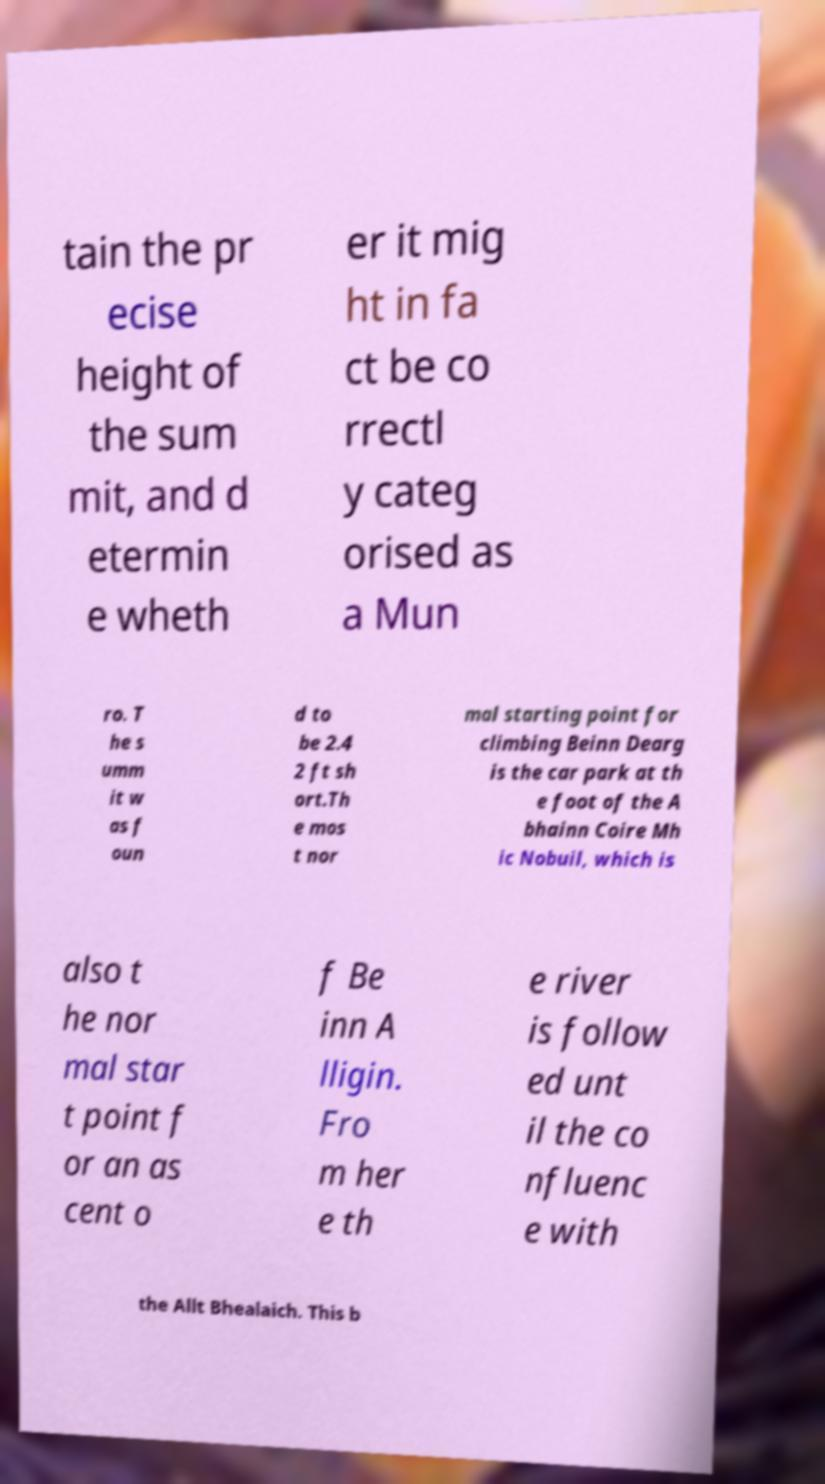Can you read and provide the text displayed in the image?This photo seems to have some interesting text. Can you extract and type it out for me? tain the pr ecise height of the sum mit, and d etermin e wheth er it mig ht in fa ct be co rrectl y categ orised as a Mun ro. T he s umm it w as f oun d to be 2.4 2 ft sh ort.Th e mos t nor mal starting point for climbing Beinn Dearg is the car park at th e foot of the A bhainn Coire Mh ic Nobuil, which is also t he nor mal star t point f or an as cent o f Be inn A lligin. Fro m her e th e river is follow ed unt il the co nfluenc e with the Allt Bhealaich. This b 